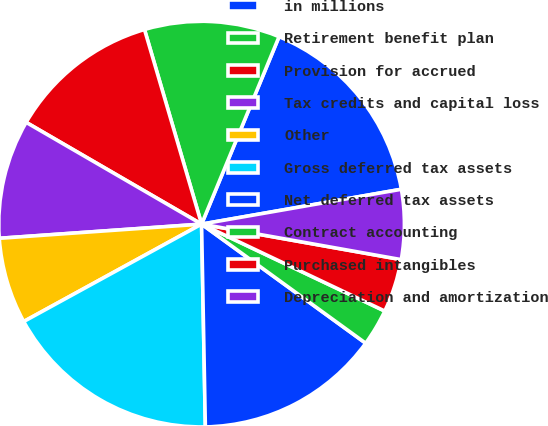<chart> <loc_0><loc_0><loc_500><loc_500><pie_chart><fcel>in millions<fcel>Retirement benefit plan<fcel>Provision for accrued<fcel>Tax credits and capital loss<fcel>Other<fcel>Gross deferred tax assets<fcel>Net deferred tax assets<fcel>Contract accounting<fcel>Purchased intangibles<fcel>Depreciation and amortization<nl><fcel>16.01%<fcel>10.78%<fcel>12.09%<fcel>9.48%<fcel>6.86%<fcel>17.32%<fcel>14.71%<fcel>2.94%<fcel>4.25%<fcel>5.55%<nl></chart> 